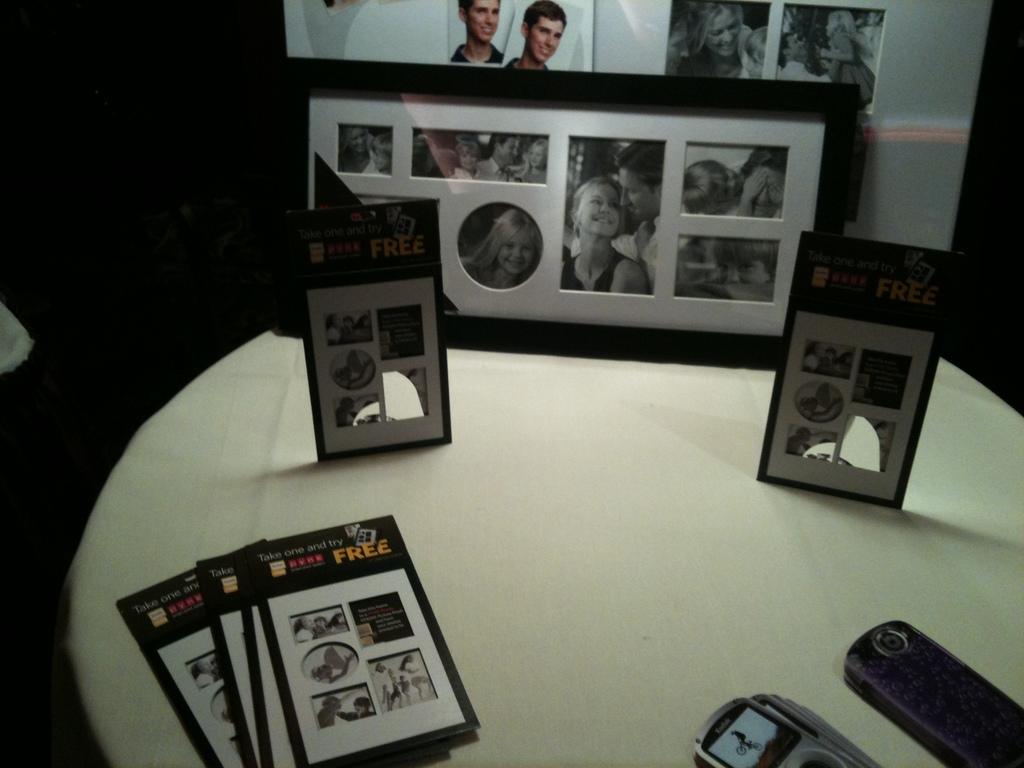What is on the frame?
Offer a terse response. Free. Are these family photoes?
Make the answer very short. Yes. 